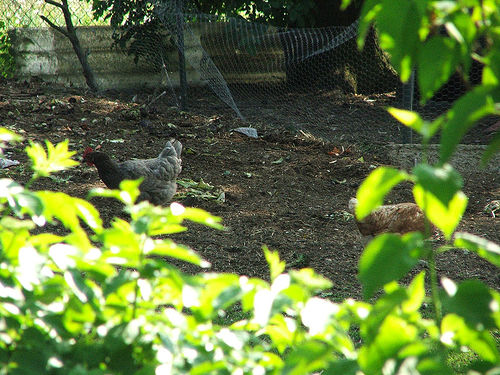<image>
Is the ken behind the net? Yes. From this viewpoint, the ken is positioned behind the net, with the net partially or fully occluding the ken. Where is the metal in relation to the chicken? Is it behind the chicken? Yes. From this viewpoint, the metal is positioned behind the chicken, with the chicken partially or fully occluding the metal. 